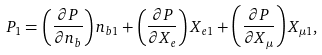<formula> <loc_0><loc_0><loc_500><loc_500>P _ { 1 } = \left ( \frac { \partial P } { \partial n _ { b } } \right ) n _ { b 1 } + \left ( \frac { \partial P } { \partial X _ { e } } \right ) X _ { e 1 } + \left ( \frac { \partial P } { \partial X _ { \mu } } \right ) X _ { \mu 1 } ,</formula> 